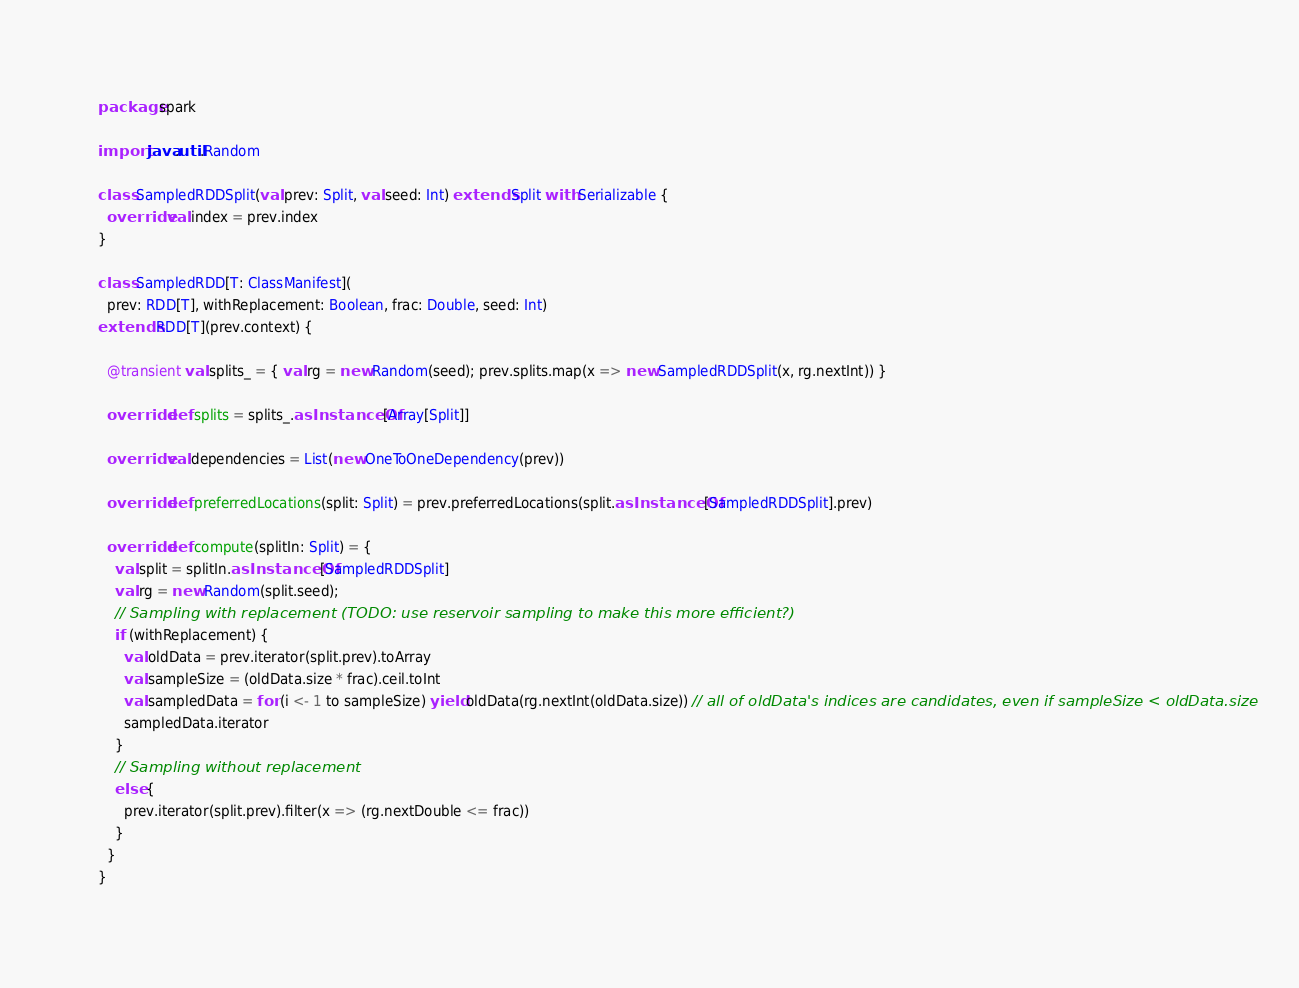Convert code to text. <code><loc_0><loc_0><loc_500><loc_500><_Scala_>package spark

import java.util.Random

class SampledRDDSplit(val prev: Split, val seed: Int) extends Split with Serializable {
  override val index = prev.index
}

class SampledRDD[T: ClassManifest](
  prev: RDD[T], withReplacement: Boolean, frac: Double, seed: Int)
extends RDD[T](prev.context) {

  @transient val splits_ = { val rg = new Random(seed); prev.splits.map(x => new SampledRDDSplit(x, rg.nextInt)) }

  override def splits = splits_.asInstanceOf[Array[Split]]

  override val dependencies = List(new OneToOneDependency(prev))
  
  override def preferredLocations(split: Split) = prev.preferredLocations(split.asInstanceOf[SampledRDDSplit].prev)

  override def compute(splitIn: Split) = {
    val split = splitIn.asInstanceOf[SampledRDDSplit]
    val rg = new Random(split.seed);
    // Sampling with replacement (TODO: use reservoir sampling to make this more efficient?)
    if (withReplacement) {
      val oldData = prev.iterator(split.prev).toArray
      val sampleSize = (oldData.size * frac).ceil.toInt
      val sampledData = for (i <- 1 to sampleSize) yield oldData(rg.nextInt(oldData.size)) // all of oldData's indices are candidates, even if sampleSize < oldData.size
      sampledData.iterator
    }
    // Sampling without replacement
    else {
      prev.iterator(split.prev).filter(x => (rg.nextDouble <= frac))
    }
  }
}
</code> 